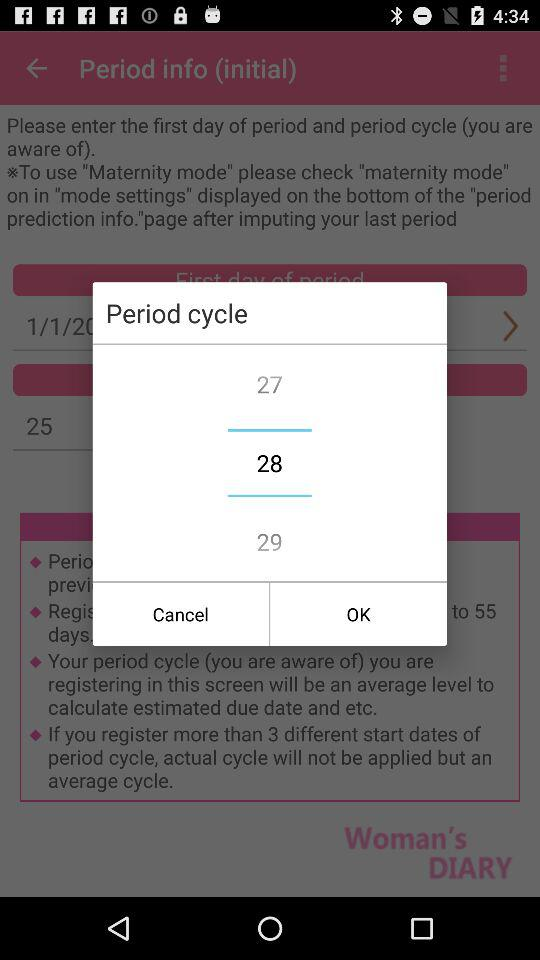What is the selected period cycle? The selected period cycle is 28. 